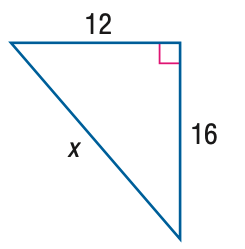Question: Find x.
Choices:
A. 18
B. 20
C. 22
D. 24
Answer with the letter. Answer: B 